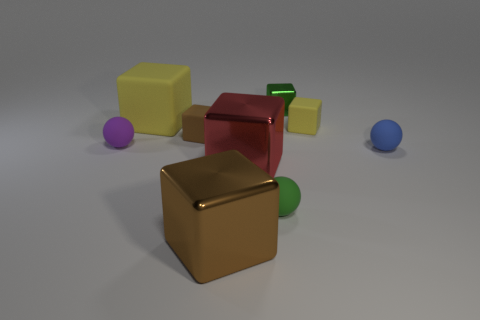Subtract all green shiny cubes. How many cubes are left? 5 Add 1 yellow things. How many objects exist? 10 Subtract all blue spheres. How many spheres are left? 2 Subtract all yellow spheres. How many brown cubes are left? 2 Subtract all cubes. How many objects are left? 3 Subtract 2 cubes. How many cubes are left? 4 Add 6 small red blocks. How many small red blocks exist? 6 Subtract 0 brown cylinders. How many objects are left? 9 Subtract all purple blocks. Subtract all yellow cylinders. How many blocks are left? 6 Subtract all tiny red matte things. Subtract all green objects. How many objects are left? 7 